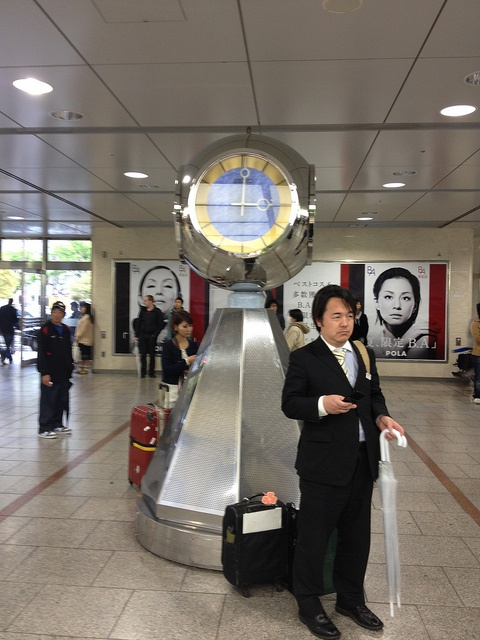Describe the objects in this image and their specific colors. I can see people in gray, black, and tan tones, clock in gray, lightgray, khaki, tan, and lavender tones, suitcase in gray, black, darkgray, and lightgray tones, people in gray, black, darkgray, and maroon tones, and suitcase in gray, maroon, and black tones in this image. 